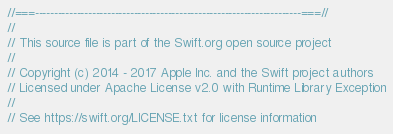<code> <loc_0><loc_0><loc_500><loc_500><_ObjectiveC_>//===----------------------------------------------------------------------===//
//
// This source file is part of the Swift.org open source project
//
// Copyright (c) 2014 - 2017 Apple Inc. and the Swift project authors
// Licensed under Apache License v2.0 with Runtime Library Exception
//
// See https://swift.org/LICENSE.txt for license information</code> 